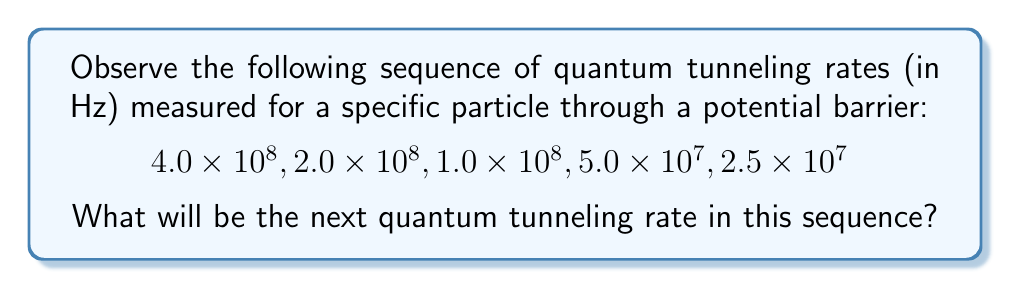Show me your answer to this math problem. To identify the pattern in this sequence of quantum tunneling rates, we need to analyze how each term relates to the previous one:

1) From $4.0 \times 10^8$ to $2.0 \times 10^8$:
   $2.0 \times 10^8 = (4.0 \times 10^8) \times \frac{1}{2}$

2) From $2.0 \times 10^8$ to $1.0 \times 10^8$:
   $1.0 \times 10^8 = (2.0 \times 10^8) \times \frac{1}{2}$

3) From $1.0 \times 10^8$ to $5.0 \times 10^7$:
   $5.0 \times 10^7 = (1.0 \times 10^8) \times \frac{1}{2}$

4) From $5.0 \times 10^7$ to $2.5 \times 10^7$:
   $2.5 \times 10^7 = (5.0 \times 10^7) \times \frac{1}{2}$

We can see that each term is half of the previous term. This forms a geometric sequence with a common ratio of $\frac{1}{2}$.

To find the next term, we multiply the last term by $\frac{1}{2}$:

$2.5 \times 10^7 \times \frac{1}{2} = 1.25 \times 10^7$ Hz

Therefore, the next quantum tunneling rate in the sequence will be $1.25 \times 10^7$ Hz.
Answer: $1.25 \times 10^7$ Hz 